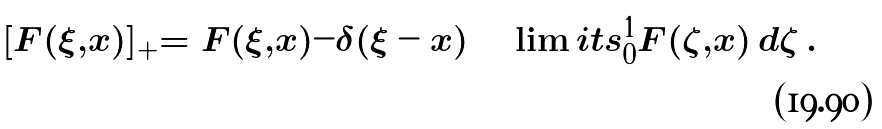<formula> <loc_0><loc_0><loc_500><loc_500>[ F ( \xi , x ) ] _ { + } = F ( \xi , x ) - \delta ( \xi - x ) \int \lim i t s _ { 0 } ^ { 1 } F ( \zeta , x ) \, d \zeta \, .</formula> 